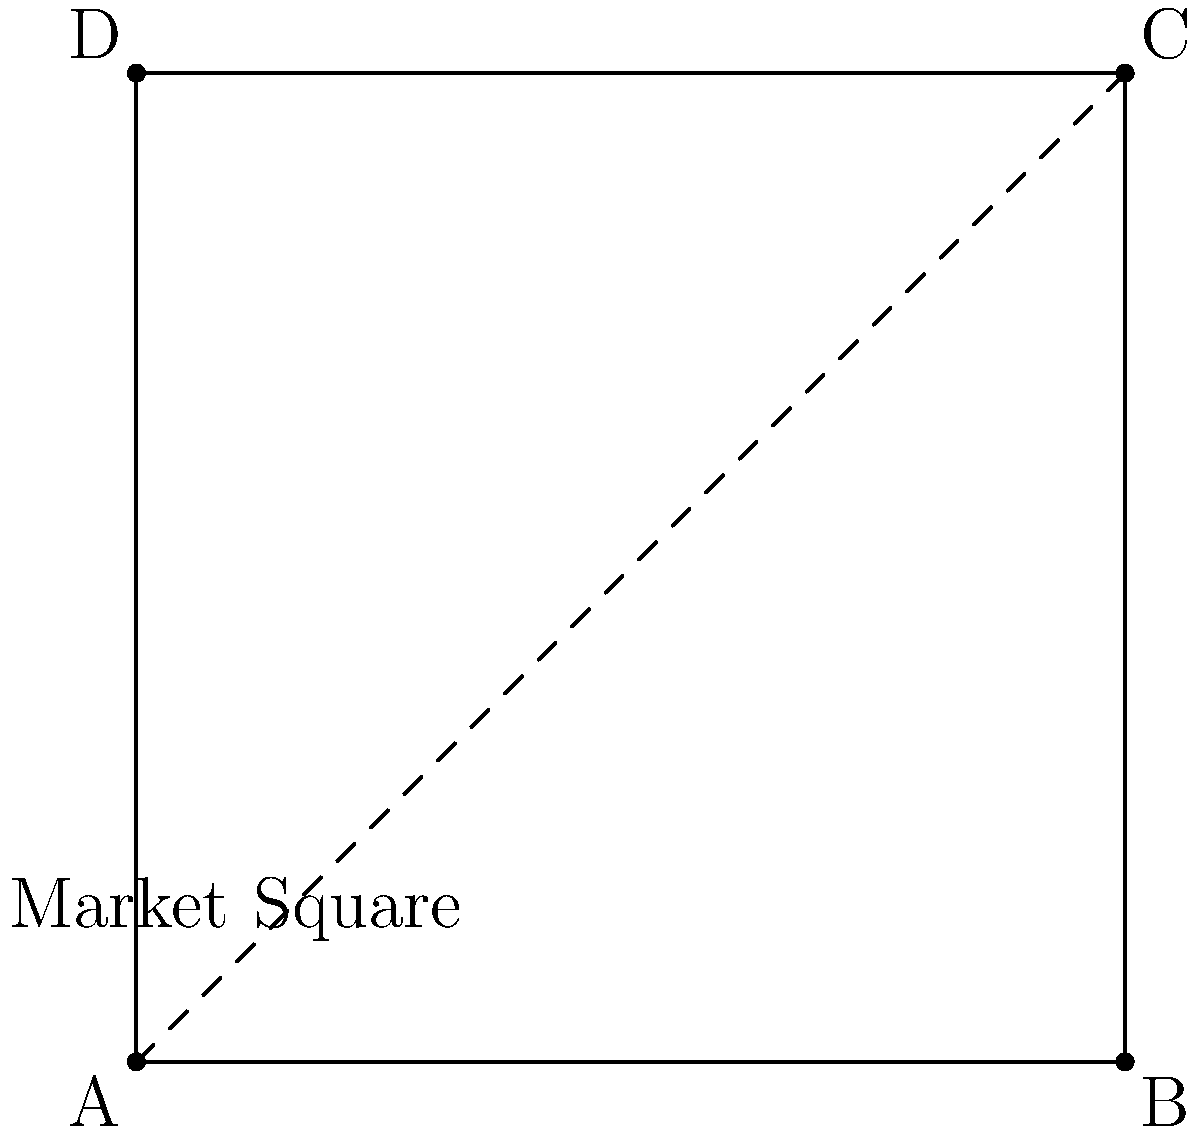In Northampton's central market square, there are two popular shops located at opposite corners: a bakery at point A and a grocery store at point C. The square measures 100 meters on each side. You need to quickly walk from the bakery to the grocery store. Which path is shorter and by how much: going along the edges of the square (A to B to C) or cutting diagonally across the square (directly from A to C)? Let's approach this step-by-step:

1) First, let's calculate the distance along the edges:
   - This path follows two sides of the square, each 100 meters long.
   - Total distance = 100 m + 100 m = 200 meters

2) Now, let's calculate the diagonal distance:
   - The diagonal forms the hypotenuse of a right-angled triangle.
   - We can use the Pythagorean theorem: $a^2 + b^2 = c^2$
   - Here, $a = b = 100$ meters (the sides of the square)
   - So, $c^2 = 100^2 + 100^2 = 20,000$
   - $c = \sqrt{20,000} = 10\sqrt{200} \approx 141.4$ meters

3) Comparing the two paths:
   - Edge path: 200 meters
   - Diagonal path: approximately 141.4 meters

4) The difference:
   200 - 141.4 = 58.6 meters

Therefore, the diagonal path is shorter by approximately 58.6 meters.
Answer: The diagonal path is shorter by about 58.6 meters. 